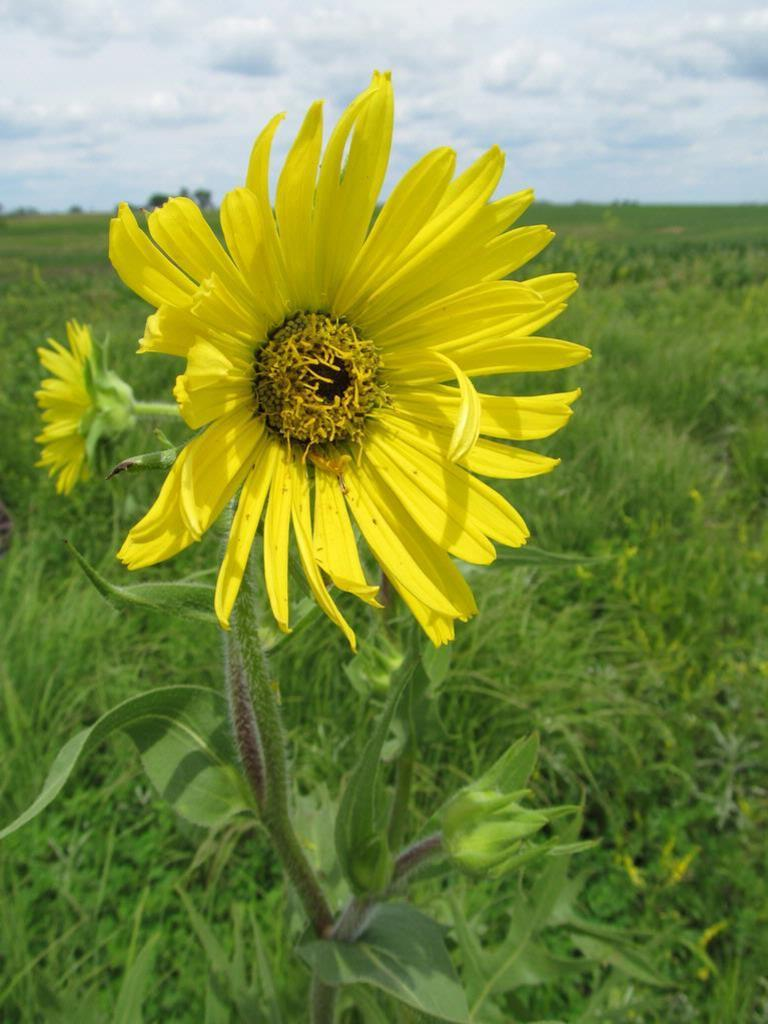What type of plant is present in the image? There is a plant with flowers and buds in the image. What type of vegetation can be seen besides the plant? There is grass visible in the image. What can be seen in the background of the image? The sky is visible in the background of the image. What type of mouth can be seen on the plant in the image? There is no mouth present on the plant in the image, as plants do not have mouths. 